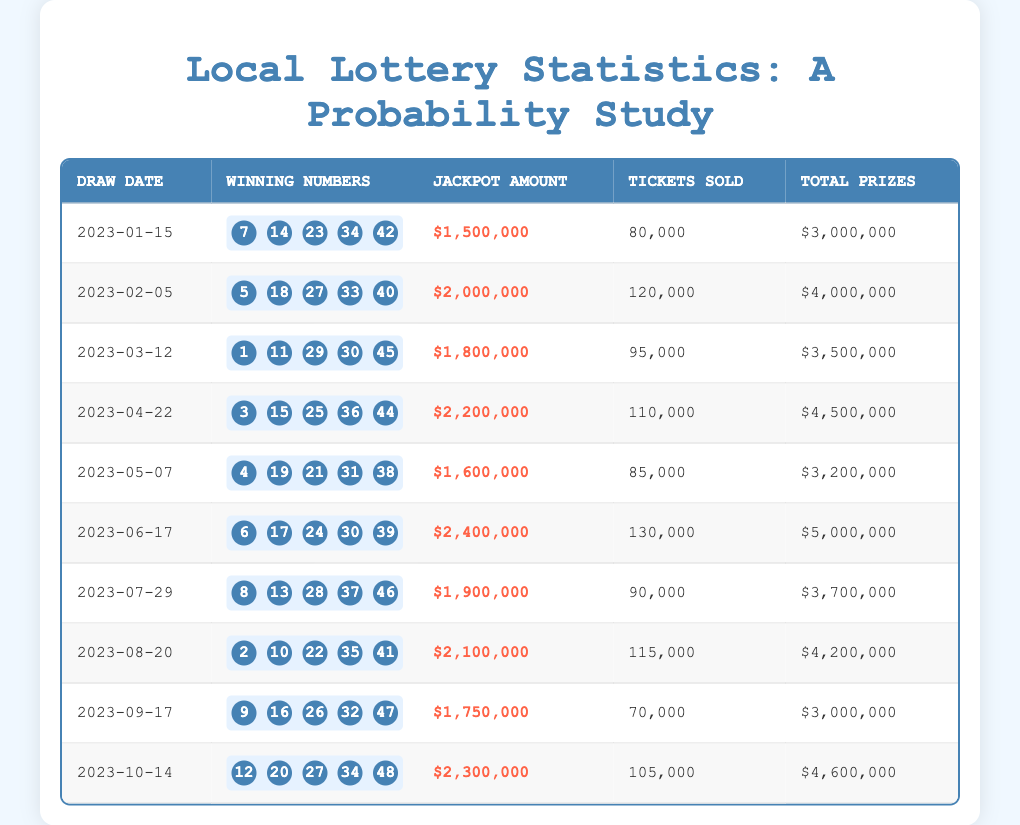What is the jackpot amount for the draw on March 12, 2023? The table shows that the jackpot amount for the draw dated March 12, 2023, is listed directly in the corresponding row under the 'Jackpot Amount' column. It is $1,800,000.
Answer: $1,800,000 How many tickets were sold for the draw on June 17, 2023? From the table, in the row for the June 17, 2023 draw, the number of tickets sold is specifically mentioned under the 'Tickets Sold' column. It is 130,000 tickets.
Answer: 130,000 What is the total prize distribution from the draws held in 2023? To find the total prize distribution, we must sum the values from the 'Total Prizes' column for all entries in the table. Adding them gives $3,000,000 + $4,000,000 + $3,500,000 + $4,500,000 + $3,200,000 + $5,000,000 + $3,700,000 + $4,200,000 + $3,000,000 + $4,600,000 = $39,700,000.
Answer: $39,700,000 Was the jackpot amount for the draw on August 20, 2023, greater than $2,000,000? The jackpot amount for the August 20, 2023 draw is $2,100,000, which is greater than $2,000,000. Therefore, the statement is true.
Answer: Yes What is the average jackpot amount for the draws held in the first half of the year (January to June)? To calculate the average jackpot for the first half of the year, we sum the jackpot amounts for January ($1,500,000), February ($2,000,000), March ($1,800,000), April ($2,200,000), May ($1,600,000), and June ($2,400,000). The sum is $1,500,000 + $2,000,000 + $1,800,000 + $2,200,000 + $1,600,000 + $2,400,000 = $11,500,000. As there are 6 drawings, we divide this total by 6, giving $11,500,000 / 6 = $1,916,666.67.
Answer: $1,916,666.67 How many draws had total prizes exceeding $4,000,000? By examining the 'Total Prizes' column, we identify the rows where the total prizes exceed $4,000,000. These rows correspond to the draws held on February (4,000,000), April (4,500,000), June (5,000,000), August (4,200,000), and October (4,600,000). Counting these rows, we see there are 5 draws.
Answer: 5 What was the highest jackpot amount recorded in the data? Looking through the 'Jackpot Amount' column, we find the maximum jackpot was $2,400,000 on June 17, 2023. We must compare each jackpot and find that this is indeed the highest amount.
Answer: $2,400,000 Which month had the least number of tickets sold? To determine this, we look through the 'Tickets Sold' column and check the values: January (80,000), February (120,000), March (95,000), April (110,000), May (85,000), June (130,000), July (90,000), August (115,000), September (70,000), October (105,000). The draw on September 17, 2023, had the least tickets sold, at 70,000.
Answer: September Which two draws had jackpot amounts closest to each other? By examining the jackpot amounts, we see they are $1,500,000 (Jan), $2,000,000 (Feb), $1,800,000 (Mar), $2,200,000 (Apr), $1,600,000 (May), $2,400,000 (Jun), $1,900,000 (Jul), $2,100,000 (Aug), $1,750,000 (Sep), $2,300,000 (Oct). The closest values are $1,800,000 (Mar) and $1,900,000 (Jul) as they differ by $100,000.
Answer: March and July 